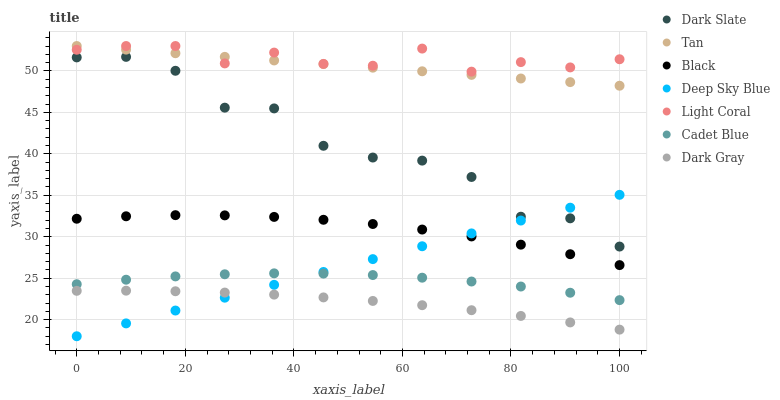Does Dark Gray have the minimum area under the curve?
Answer yes or no. Yes. Does Light Coral have the maximum area under the curve?
Answer yes or no. Yes. Does Cadet Blue have the minimum area under the curve?
Answer yes or no. No. Does Cadet Blue have the maximum area under the curve?
Answer yes or no. No. Is Deep Sky Blue the smoothest?
Answer yes or no. Yes. Is Dark Slate the roughest?
Answer yes or no. Yes. Is Cadet Blue the smoothest?
Answer yes or no. No. Is Cadet Blue the roughest?
Answer yes or no. No. Does Deep Sky Blue have the lowest value?
Answer yes or no. Yes. Does Cadet Blue have the lowest value?
Answer yes or no. No. Does Tan have the highest value?
Answer yes or no. Yes. Does Cadet Blue have the highest value?
Answer yes or no. No. Is Black less than Dark Slate?
Answer yes or no. Yes. Is Light Coral greater than Dark Slate?
Answer yes or no. Yes. Does Black intersect Deep Sky Blue?
Answer yes or no. Yes. Is Black less than Deep Sky Blue?
Answer yes or no. No. Is Black greater than Deep Sky Blue?
Answer yes or no. No. Does Black intersect Dark Slate?
Answer yes or no. No. 